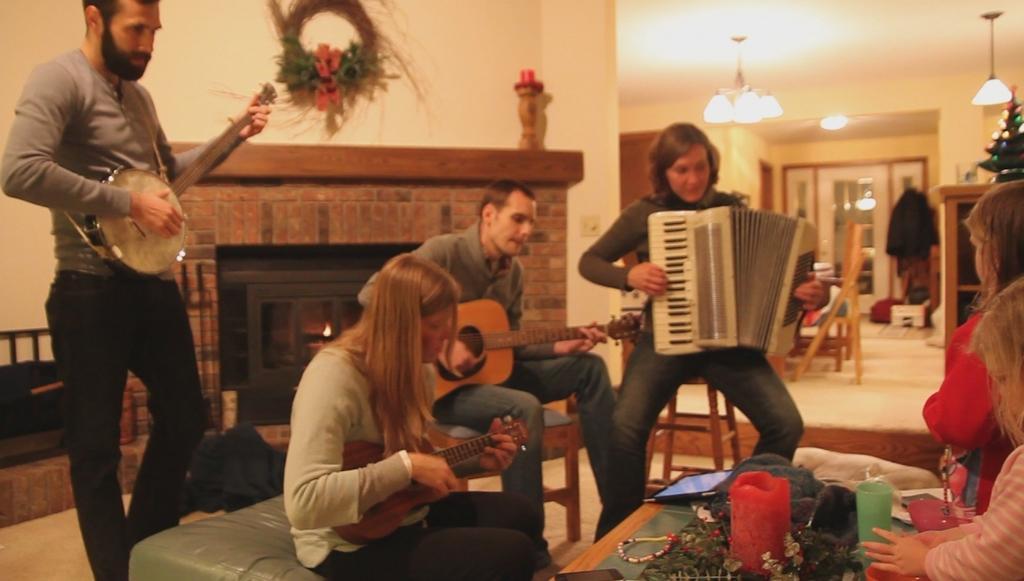Describe this image in one or two sentences. A person on the left corner is holding a musical instruments and playing. A lady is sitting on a sofa and playing a guitar. A man is also playing guitar sitting on a chair. A woman is holding accordion sitting on a stool and playing. There is a table. On the table there are some flowers , candle, tag and a glass. In the background there is a wall, flower vase and a brick wall. Also there is a chandelier, door, chairs, Christmas tree and lights in the background. 